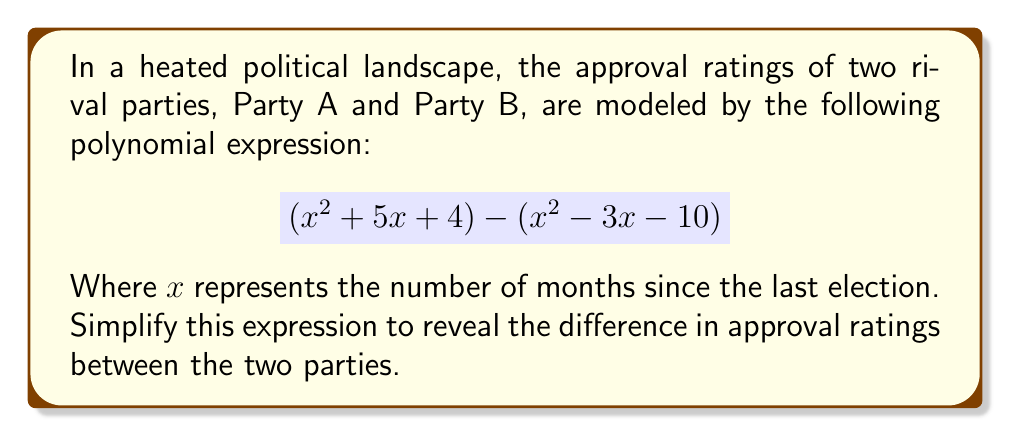Solve this math problem. Let's approach this step-by-step:

1) First, we need to identify the polynomials representing each party:
   Party A: $x^2 + 5x + 4$
   Party B: $x^2 - 3x - 10$

2) The expression represents the difference between these two polynomials:
   $$(x^2 + 5x + 4) - (x^2 - 3x - 10)$$

3) To simplify, we subtract the second polynomial from the first. When subtracting polynomials, we subtract the corresponding terms:

   $x^2 + 5x + 4$
   $-(x^2 - 3x - 10)$

4) Subtracting a negative is the same as adding, so we change the signs of the second polynomial:

   $x^2 + 5x + 4$
   $+(-x^2 + 3x + 10)$

5) Now we can combine like terms:
   
   $x^2 - x^2 = 0$
   $5x + 3x = 8x$
   $4 + 10 = 14$

6) Therefore, the simplified expression is:

   $8x + 14$

This simplified polynomial represents the difference in approval ratings between Party A and Party B, $x$ months after the last election.
Answer: $8x + 14$ 